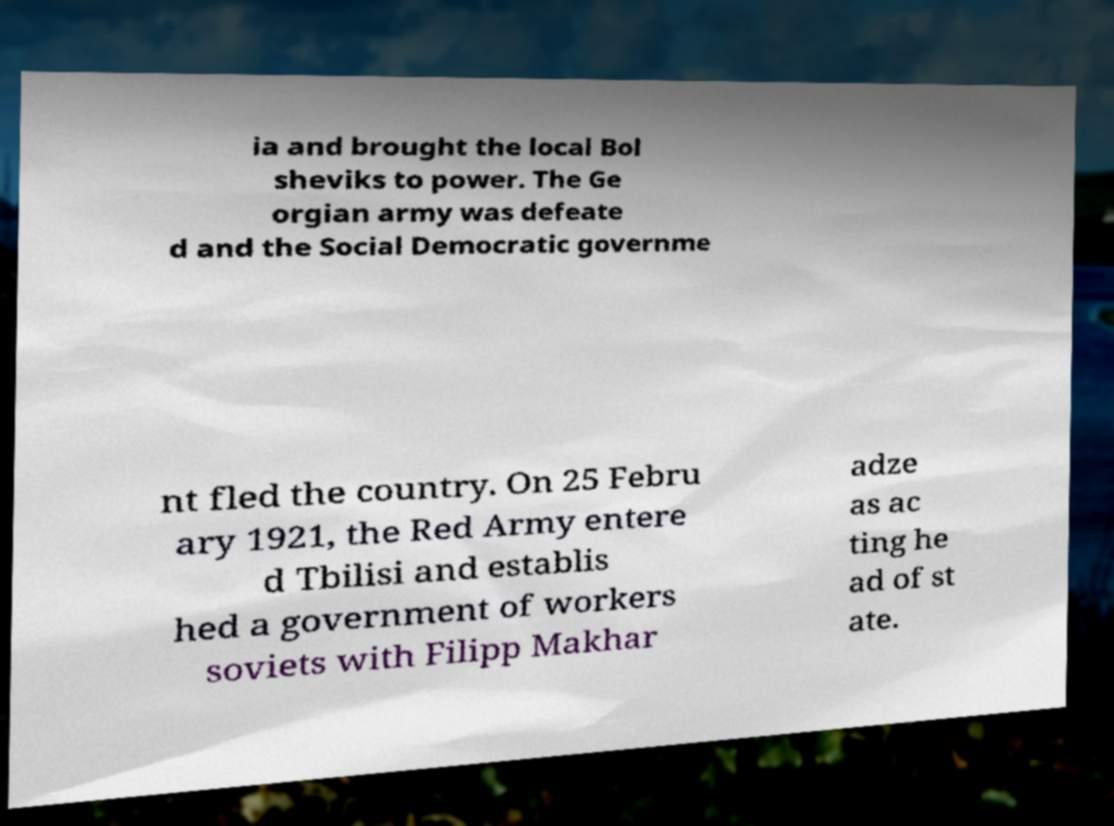Can you read and provide the text displayed in the image?This photo seems to have some interesting text. Can you extract and type it out for me? ia and brought the local Bol sheviks to power. The Ge orgian army was defeate d and the Social Democratic governme nt fled the country. On 25 Febru ary 1921, the Red Army entere d Tbilisi and establis hed a government of workers soviets with Filipp Makhar adze as ac ting he ad of st ate. 